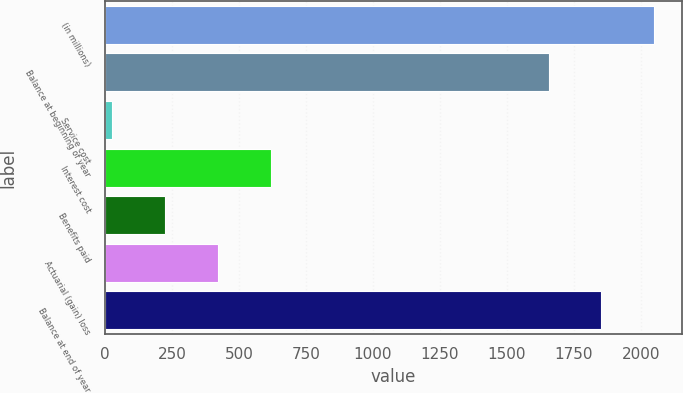<chart> <loc_0><loc_0><loc_500><loc_500><bar_chart><fcel>(in millions)<fcel>Balance at beginning of year<fcel>Service cost<fcel>Interest cost<fcel>Benefits paid<fcel>Actuarial (gain) loss<fcel>Balance at end of year<nl><fcel>2050.4<fcel>1655<fcel>27<fcel>620.1<fcel>224.7<fcel>422.4<fcel>1852.7<nl></chart> 